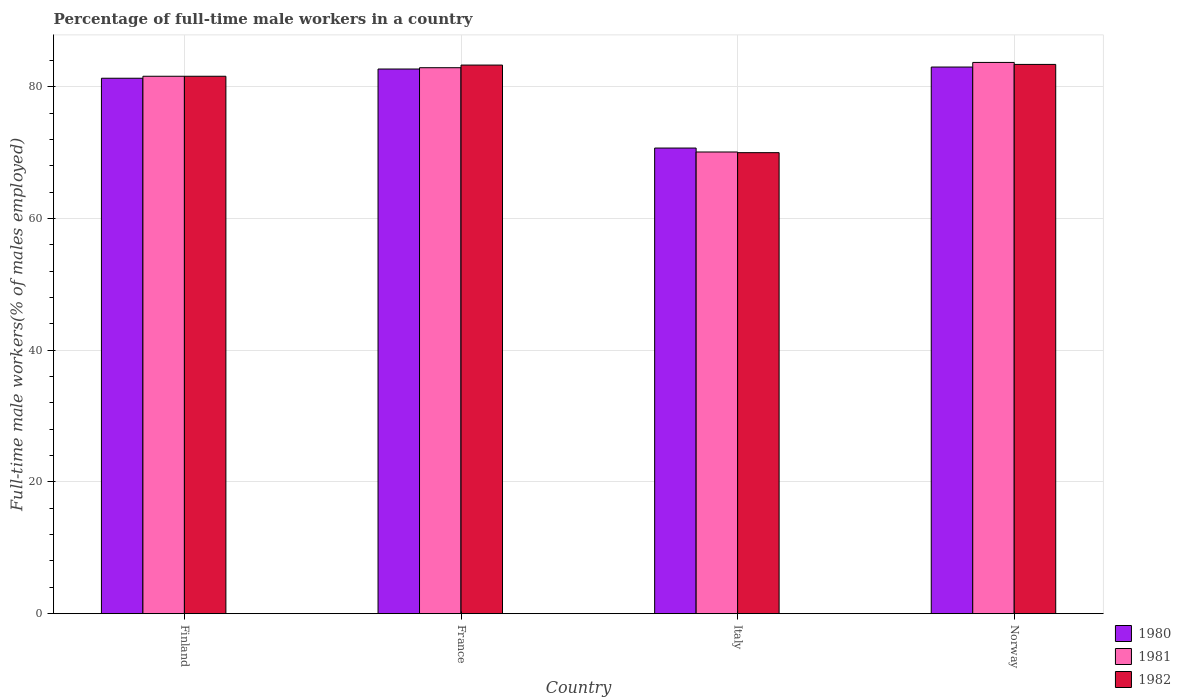Are the number of bars per tick equal to the number of legend labels?
Keep it short and to the point. Yes. How many bars are there on the 4th tick from the left?
Give a very brief answer. 3. What is the label of the 2nd group of bars from the left?
Offer a very short reply. France. What is the percentage of full-time male workers in 1982 in France?
Keep it short and to the point. 83.3. Across all countries, what is the maximum percentage of full-time male workers in 1981?
Your answer should be very brief. 83.7. Across all countries, what is the minimum percentage of full-time male workers in 1981?
Ensure brevity in your answer.  70.1. In which country was the percentage of full-time male workers in 1982 maximum?
Make the answer very short. Norway. What is the total percentage of full-time male workers in 1981 in the graph?
Your answer should be compact. 318.3. What is the difference between the percentage of full-time male workers in 1982 in Finland and that in Norway?
Your response must be concise. -1.8. What is the difference between the percentage of full-time male workers in 1980 in Italy and the percentage of full-time male workers in 1981 in France?
Ensure brevity in your answer.  -12.2. What is the average percentage of full-time male workers in 1982 per country?
Your response must be concise. 79.58. What is the difference between the percentage of full-time male workers of/in 1981 and percentage of full-time male workers of/in 1982 in Italy?
Your response must be concise. 0.1. In how many countries, is the percentage of full-time male workers in 1980 greater than 64 %?
Offer a terse response. 4. What is the ratio of the percentage of full-time male workers in 1982 in France to that in Italy?
Keep it short and to the point. 1.19. Is the difference between the percentage of full-time male workers in 1981 in France and Italy greater than the difference between the percentage of full-time male workers in 1982 in France and Italy?
Your response must be concise. No. What is the difference between the highest and the second highest percentage of full-time male workers in 1981?
Ensure brevity in your answer.  -1.3. What is the difference between the highest and the lowest percentage of full-time male workers in 1982?
Make the answer very short. 13.4. What does the 2nd bar from the left in Norway represents?
Make the answer very short. 1981. How many bars are there?
Your response must be concise. 12. Are all the bars in the graph horizontal?
Your answer should be very brief. No. What is the difference between two consecutive major ticks on the Y-axis?
Make the answer very short. 20. Does the graph contain grids?
Provide a short and direct response. Yes. How are the legend labels stacked?
Give a very brief answer. Vertical. What is the title of the graph?
Provide a short and direct response. Percentage of full-time male workers in a country. What is the label or title of the X-axis?
Provide a short and direct response. Country. What is the label or title of the Y-axis?
Your answer should be compact. Full-time male workers(% of males employed). What is the Full-time male workers(% of males employed) of 1980 in Finland?
Your answer should be very brief. 81.3. What is the Full-time male workers(% of males employed) in 1981 in Finland?
Provide a succinct answer. 81.6. What is the Full-time male workers(% of males employed) of 1982 in Finland?
Keep it short and to the point. 81.6. What is the Full-time male workers(% of males employed) of 1980 in France?
Your answer should be compact. 82.7. What is the Full-time male workers(% of males employed) in 1981 in France?
Ensure brevity in your answer.  82.9. What is the Full-time male workers(% of males employed) in 1982 in France?
Your response must be concise. 83.3. What is the Full-time male workers(% of males employed) of 1980 in Italy?
Keep it short and to the point. 70.7. What is the Full-time male workers(% of males employed) in 1981 in Italy?
Make the answer very short. 70.1. What is the Full-time male workers(% of males employed) in 1981 in Norway?
Provide a short and direct response. 83.7. What is the Full-time male workers(% of males employed) of 1982 in Norway?
Ensure brevity in your answer.  83.4. Across all countries, what is the maximum Full-time male workers(% of males employed) in 1980?
Your answer should be very brief. 83. Across all countries, what is the maximum Full-time male workers(% of males employed) in 1981?
Ensure brevity in your answer.  83.7. Across all countries, what is the maximum Full-time male workers(% of males employed) in 1982?
Ensure brevity in your answer.  83.4. Across all countries, what is the minimum Full-time male workers(% of males employed) in 1980?
Ensure brevity in your answer.  70.7. Across all countries, what is the minimum Full-time male workers(% of males employed) of 1981?
Ensure brevity in your answer.  70.1. Across all countries, what is the minimum Full-time male workers(% of males employed) in 1982?
Keep it short and to the point. 70. What is the total Full-time male workers(% of males employed) in 1980 in the graph?
Your answer should be very brief. 317.7. What is the total Full-time male workers(% of males employed) in 1981 in the graph?
Your response must be concise. 318.3. What is the total Full-time male workers(% of males employed) of 1982 in the graph?
Offer a very short reply. 318.3. What is the difference between the Full-time male workers(% of males employed) in 1980 in Finland and that in France?
Provide a succinct answer. -1.4. What is the difference between the Full-time male workers(% of males employed) in 1981 in Finland and that in France?
Your response must be concise. -1.3. What is the difference between the Full-time male workers(% of males employed) of 1980 in Finland and that in Italy?
Offer a terse response. 10.6. What is the difference between the Full-time male workers(% of males employed) in 1981 in Finland and that in Italy?
Keep it short and to the point. 11.5. What is the difference between the Full-time male workers(% of males employed) of 1980 in Finland and that in Norway?
Make the answer very short. -1.7. What is the difference between the Full-time male workers(% of males employed) in 1981 in Finland and that in Norway?
Your response must be concise. -2.1. What is the difference between the Full-time male workers(% of males employed) in 1981 in France and that in Italy?
Your answer should be compact. 12.8. What is the difference between the Full-time male workers(% of males employed) in 1982 in France and that in Italy?
Your answer should be compact. 13.3. What is the difference between the Full-time male workers(% of males employed) of 1980 in France and that in Norway?
Provide a short and direct response. -0.3. What is the difference between the Full-time male workers(% of males employed) of 1980 in Italy and that in Norway?
Provide a short and direct response. -12.3. What is the difference between the Full-time male workers(% of males employed) of 1981 in Italy and that in Norway?
Offer a very short reply. -13.6. What is the difference between the Full-time male workers(% of males employed) of 1980 in Finland and the Full-time male workers(% of males employed) of 1981 in France?
Provide a succinct answer. -1.6. What is the difference between the Full-time male workers(% of males employed) in 1980 in Finland and the Full-time male workers(% of males employed) in 1982 in France?
Your response must be concise. -2. What is the difference between the Full-time male workers(% of males employed) of 1981 in Finland and the Full-time male workers(% of males employed) of 1982 in France?
Keep it short and to the point. -1.7. What is the difference between the Full-time male workers(% of males employed) of 1980 in Finland and the Full-time male workers(% of males employed) of 1981 in Italy?
Keep it short and to the point. 11.2. What is the difference between the Full-time male workers(% of males employed) of 1980 in Finland and the Full-time male workers(% of males employed) of 1982 in Italy?
Give a very brief answer. 11.3. What is the difference between the Full-time male workers(% of males employed) of 1981 in Finland and the Full-time male workers(% of males employed) of 1982 in Italy?
Your answer should be compact. 11.6. What is the difference between the Full-time male workers(% of males employed) of 1980 in France and the Full-time male workers(% of males employed) of 1981 in Italy?
Give a very brief answer. 12.6. What is the difference between the Full-time male workers(% of males employed) in 1980 in France and the Full-time male workers(% of males employed) in 1982 in Italy?
Provide a short and direct response. 12.7. What is the difference between the Full-time male workers(% of males employed) of 1981 in France and the Full-time male workers(% of males employed) of 1982 in Italy?
Your answer should be very brief. 12.9. What is the difference between the Full-time male workers(% of males employed) in 1980 in France and the Full-time male workers(% of males employed) in 1981 in Norway?
Offer a terse response. -1. What is the difference between the Full-time male workers(% of males employed) of 1980 in France and the Full-time male workers(% of males employed) of 1982 in Norway?
Offer a very short reply. -0.7. What is the average Full-time male workers(% of males employed) in 1980 per country?
Make the answer very short. 79.42. What is the average Full-time male workers(% of males employed) in 1981 per country?
Keep it short and to the point. 79.58. What is the average Full-time male workers(% of males employed) in 1982 per country?
Your answer should be compact. 79.58. What is the difference between the Full-time male workers(% of males employed) in 1980 and Full-time male workers(% of males employed) in 1981 in Finland?
Your answer should be very brief. -0.3. What is the difference between the Full-time male workers(% of males employed) in 1980 and Full-time male workers(% of males employed) in 1981 in France?
Provide a short and direct response. -0.2. What is the difference between the Full-time male workers(% of males employed) of 1980 and Full-time male workers(% of males employed) of 1982 in Italy?
Provide a short and direct response. 0.7. What is the difference between the Full-time male workers(% of males employed) in 1981 and Full-time male workers(% of males employed) in 1982 in Italy?
Make the answer very short. 0.1. What is the difference between the Full-time male workers(% of males employed) of 1980 and Full-time male workers(% of males employed) of 1982 in Norway?
Give a very brief answer. -0.4. What is the difference between the Full-time male workers(% of males employed) of 1981 and Full-time male workers(% of males employed) of 1982 in Norway?
Ensure brevity in your answer.  0.3. What is the ratio of the Full-time male workers(% of males employed) of 1980 in Finland to that in France?
Offer a terse response. 0.98. What is the ratio of the Full-time male workers(% of males employed) of 1981 in Finland to that in France?
Give a very brief answer. 0.98. What is the ratio of the Full-time male workers(% of males employed) in 1982 in Finland to that in France?
Your response must be concise. 0.98. What is the ratio of the Full-time male workers(% of males employed) of 1980 in Finland to that in Italy?
Ensure brevity in your answer.  1.15. What is the ratio of the Full-time male workers(% of males employed) in 1981 in Finland to that in Italy?
Keep it short and to the point. 1.16. What is the ratio of the Full-time male workers(% of males employed) of 1982 in Finland to that in Italy?
Give a very brief answer. 1.17. What is the ratio of the Full-time male workers(% of males employed) of 1980 in Finland to that in Norway?
Keep it short and to the point. 0.98. What is the ratio of the Full-time male workers(% of males employed) in 1981 in Finland to that in Norway?
Your answer should be very brief. 0.97. What is the ratio of the Full-time male workers(% of males employed) of 1982 in Finland to that in Norway?
Provide a short and direct response. 0.98. What is the ratio of the Full-time male workers(% of males employed) of 1980 in France to that in Italy?
Provide a short and direct response. 1.17. What is the ratio of the Full-time male workers(% of males employed) in 1981 in France to that in Italy?
Your answer should be compact. 1.18. What is the ratio of the Full-time male workers(% of males employed) of 1982 in France to that in Italy?
Provide a succinct answer. 1.19. What is the ratio of the Full-time male workers(% of males employed) of 1981 in France to that in Norway?
Offer a terse response. 0.99. What is the ratio of the Full-time male workers(% of males employed) of 1982 in France to that in Norway?
Offer a terse response. 1. What is the ratio of the Full-time male workers(% of males employed) in 1980 in Italy to that in Norway?
Provide a succinct answer. 0.85. What is the ratio of the Full-time male workers(% of males employed) of 1981 in Italy to that in Norway?
Provide a short and direct response. 0.84. What is the ratio of the Full-time male workers(% of males employed) in 1982 in Italy to that in Norway?
Your answer should be compact. 0.84. What is the difference between the highest and the second highest Full-time male workers(% of males employed) of 1982?
Keep it short and to the point. 0.1. What is the difference between the highest and the lowest Full-time male workers(% of males employed) in 1980?
Make the answer very short. 12.3. 